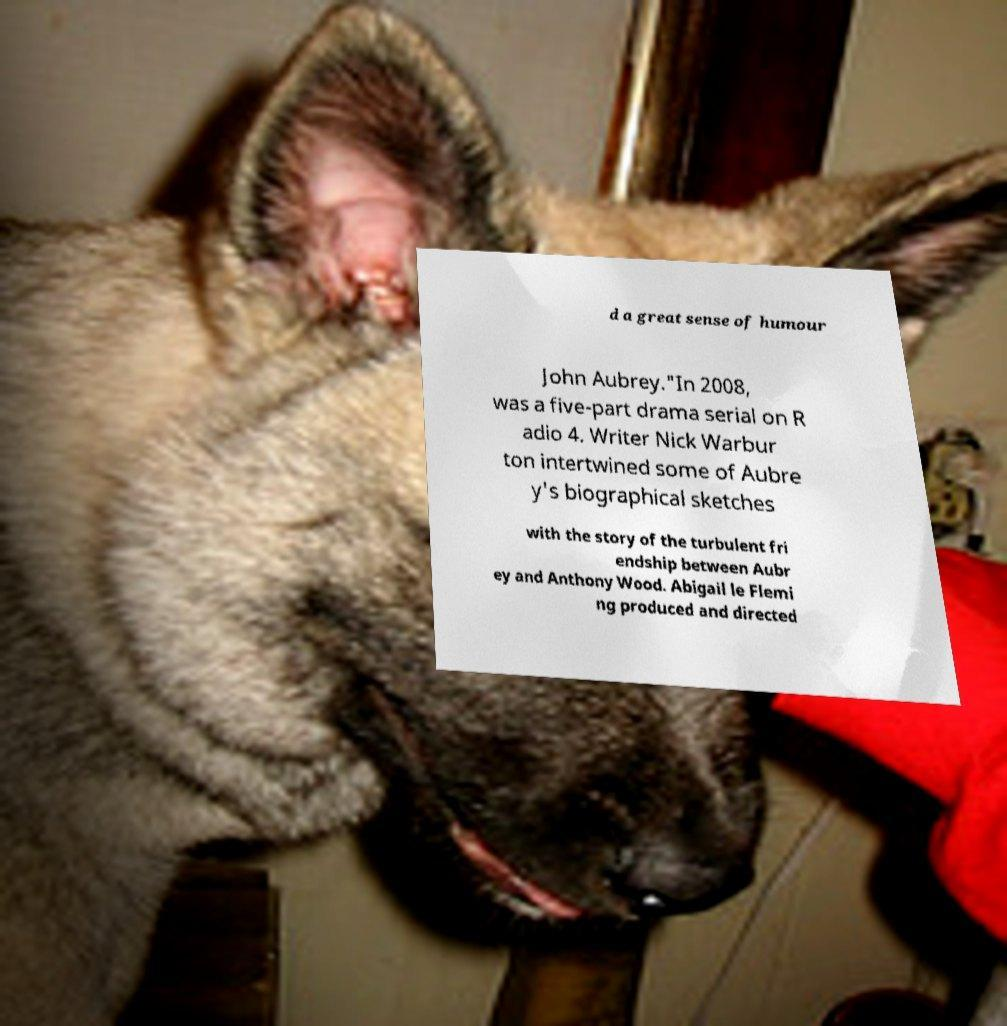Could you assist in decoding the text presented in this image and type it out clearly? d a great sense of humour John Aubrey."In 2008, was a five-part drama serial on R adio 4. Writer Nick Warbur ton intertwined some of Aubre y's biographical sketches with the story of the turbulent fri endship between Aubr ey and Anthony Wood. Abigail le Flemi ng produced and directed 